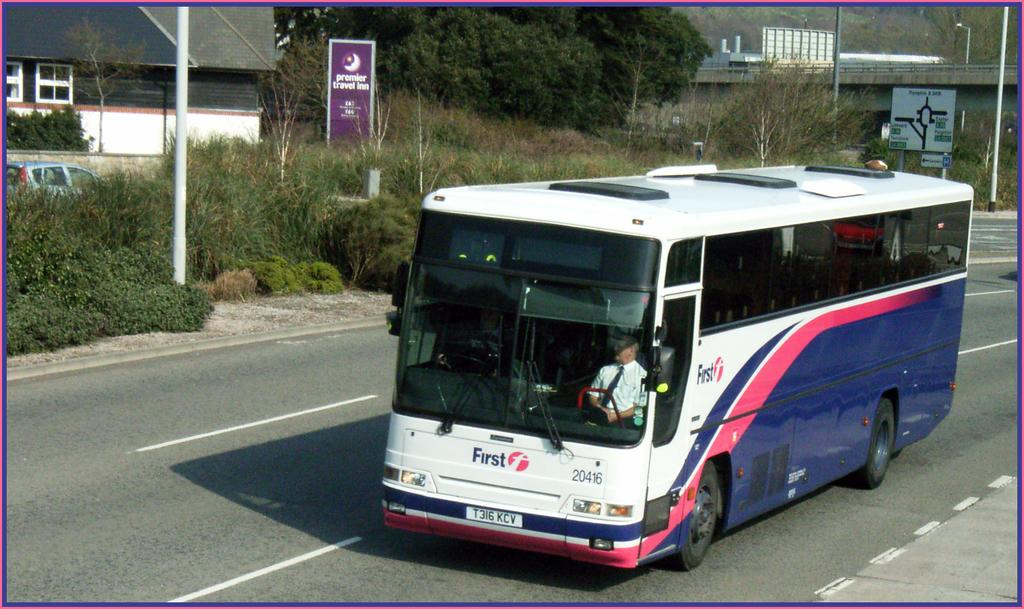What type of vegetation can be seen in the image? There are trees and bushes in the image. Where are the trees and bushes located in the image? The trees and bushes are located at the top and middle of the image. What type of structures are visible in the image? There are buildings in the image. Where are the buildings located in the image? The buildings are located at the top of the image. What mode of transportation can be seen in the image? There is a bus in the image. Where is the bus located in the image? The bus is located in the middle of the image. Is there anyone inside the bus? Yes, there is a person sitting in the bus. What type of bed can be seen in the image? There is no bed present in the image. How many arches are visible in the image? There is no mention of arches in the provided facts, so it cannot be determined from the image. 